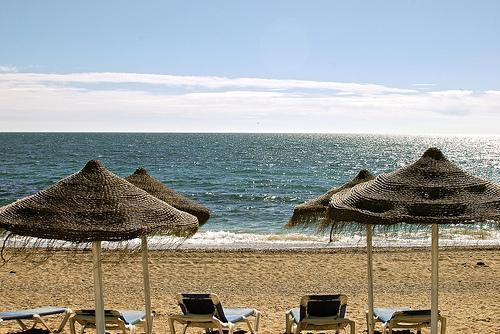How many folding chairs are there?
Give a very brief answer. 5. 